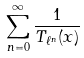Convert formula to latex. <formula><loc_0><loc_0><loc_500><loc_500>\sum _ { n = 0 } ^ { \infty } \frac { 1 } { T _ { \ell ^ { n } } ( x ) }</formula> 